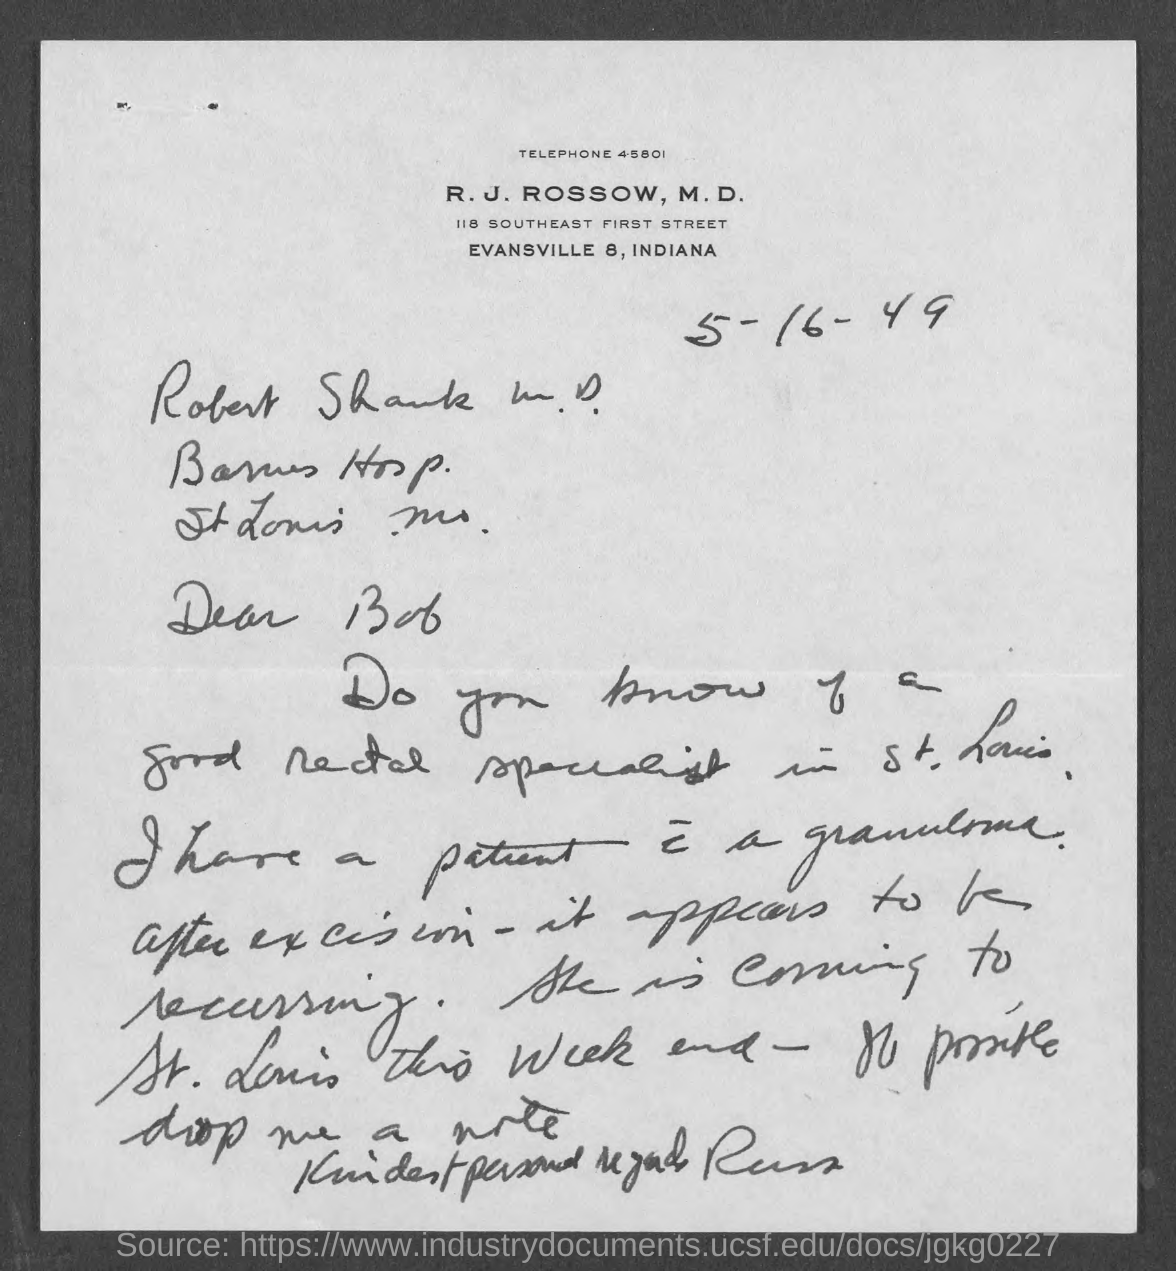Draw attention to some important aspects in this diagram. The date mentioned in the given page is 5-16-49. The telephone number mentioned in the given page is 45801... 